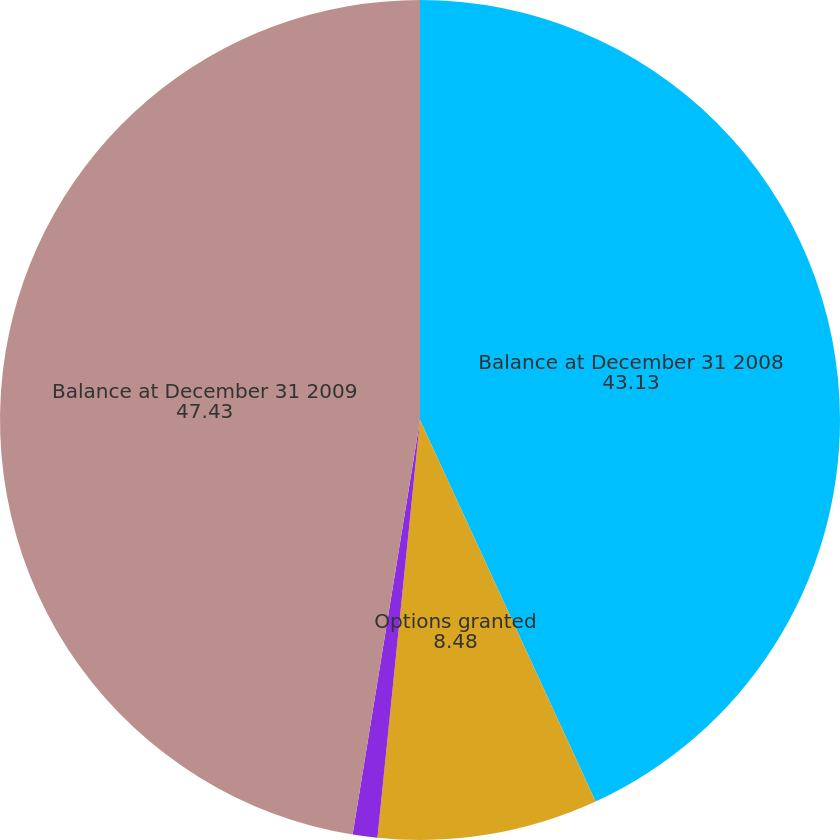Convert chart. <chart><loc_0><loc_0><loc_500><loc_500><pie_chart><fcel>Balance at December 31 2008<fcel>Options granted<fcel>Options canceled/expired<fcel>Balance at December 31 2009<nl><fcel>43.13%<fcel>8.48%<fcel>0.95%<fcel>47.43%<nl></chart> 